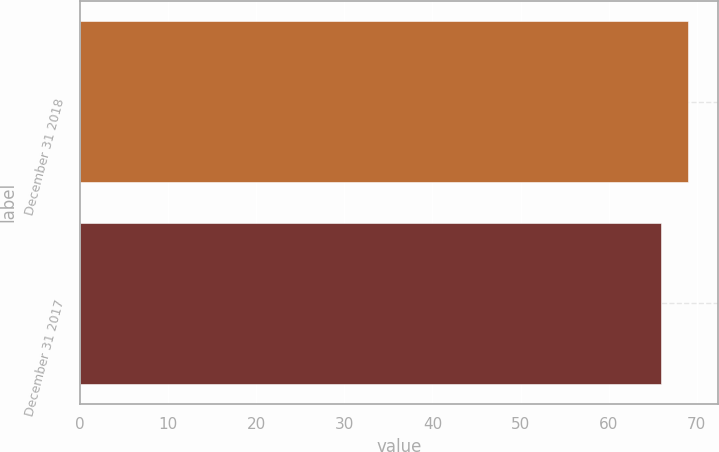Convert chart to OTSL. <chart><loc_0><loc_0><loc_500><loc_500><bar_chart><fcel>December 31 2018<fcel>December 31 2017<nl><fcel>69<fcel>66<nl></chart> 